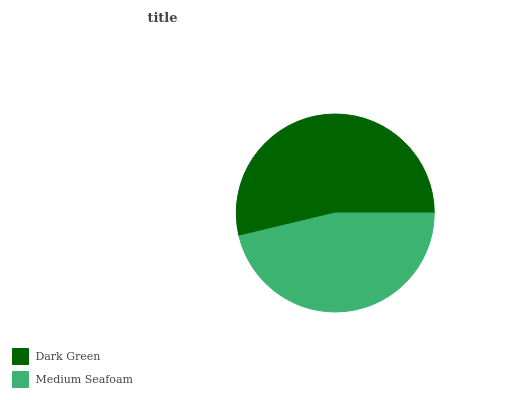Is Medium Seafoam the minimum?
Answer yes or no. Yes. Is Dark Green the maximum?
Answer yes or no. Yes. Is Medium Seafoam the maximum?
Answer yes or no. No. Is Dark Green greater than Medium Seafoam?
Answer yes or no. Yes. Is Medium Seafoam less than Dark Green?
Answer yes or no. Yes. Is Medium Seafoam greater than Dark Green?
Answer yes or no. No. Is Dark Green less than Medium Seafoam?
Answer yes or no. No. Is Dark Green the high median?
Answer yes or no. Yes. Is Medium Seafoam the low median?
Answer yes or no. Yes. Is Medium Seafoam the high median?
Answer yes or no. No. Is Dark Green the low median?
Answer yes or no. No. 